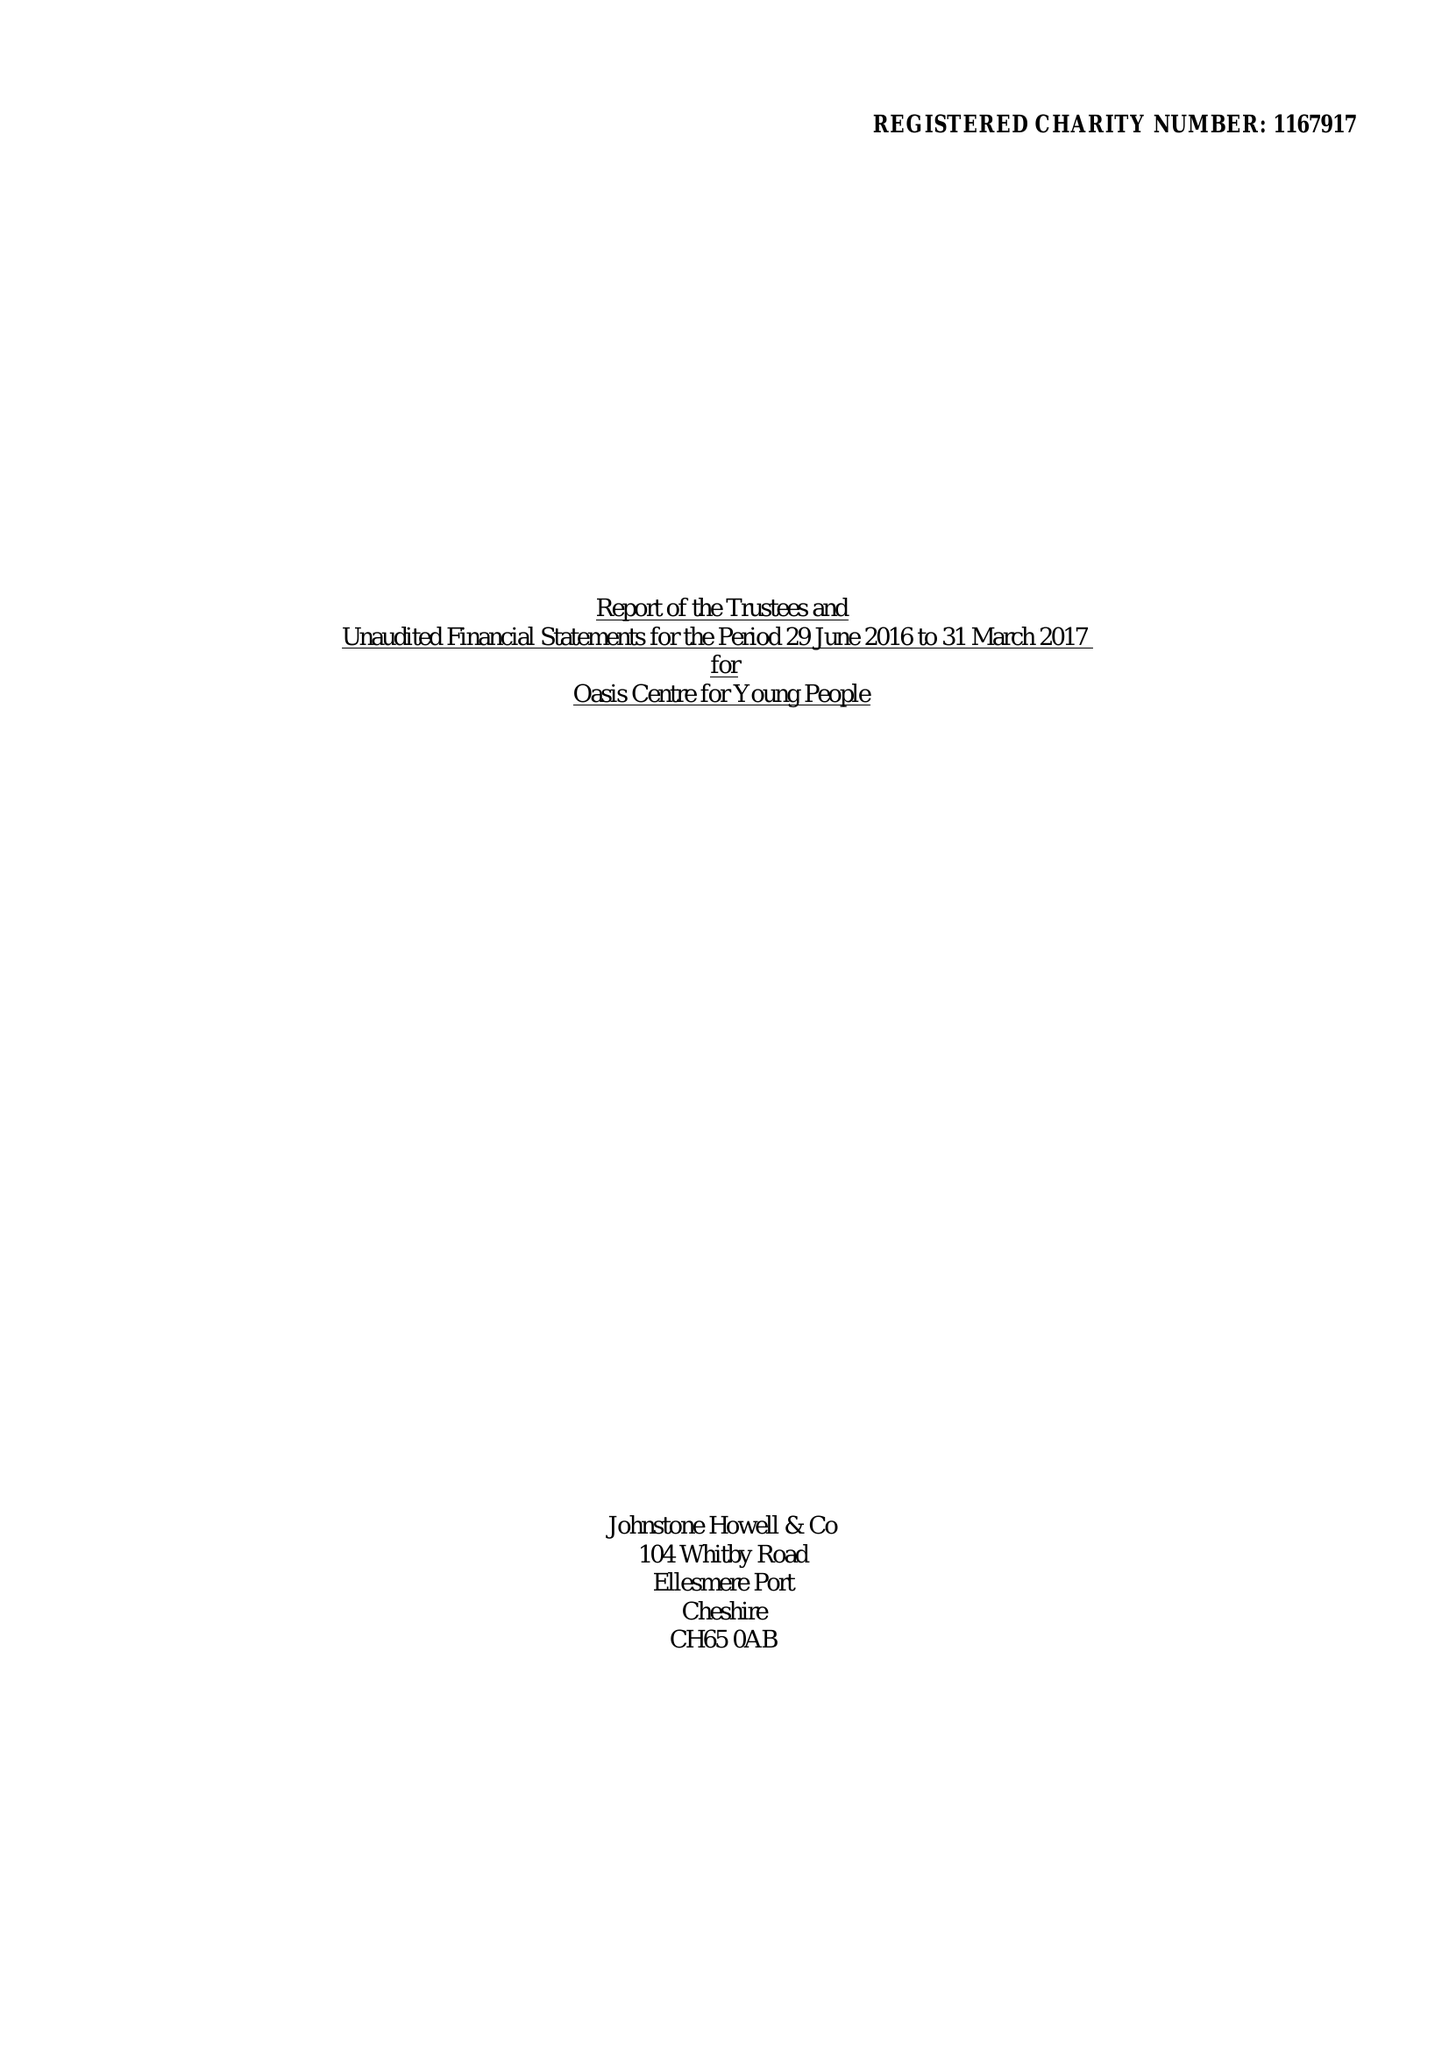What is the value for the charity_number?
Answer the question using a single word or phrase. 1167917 